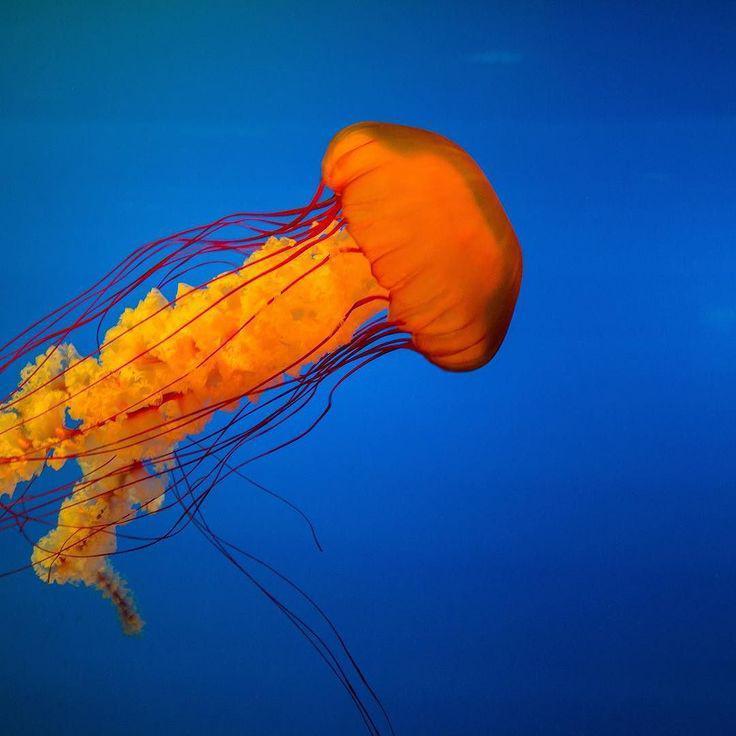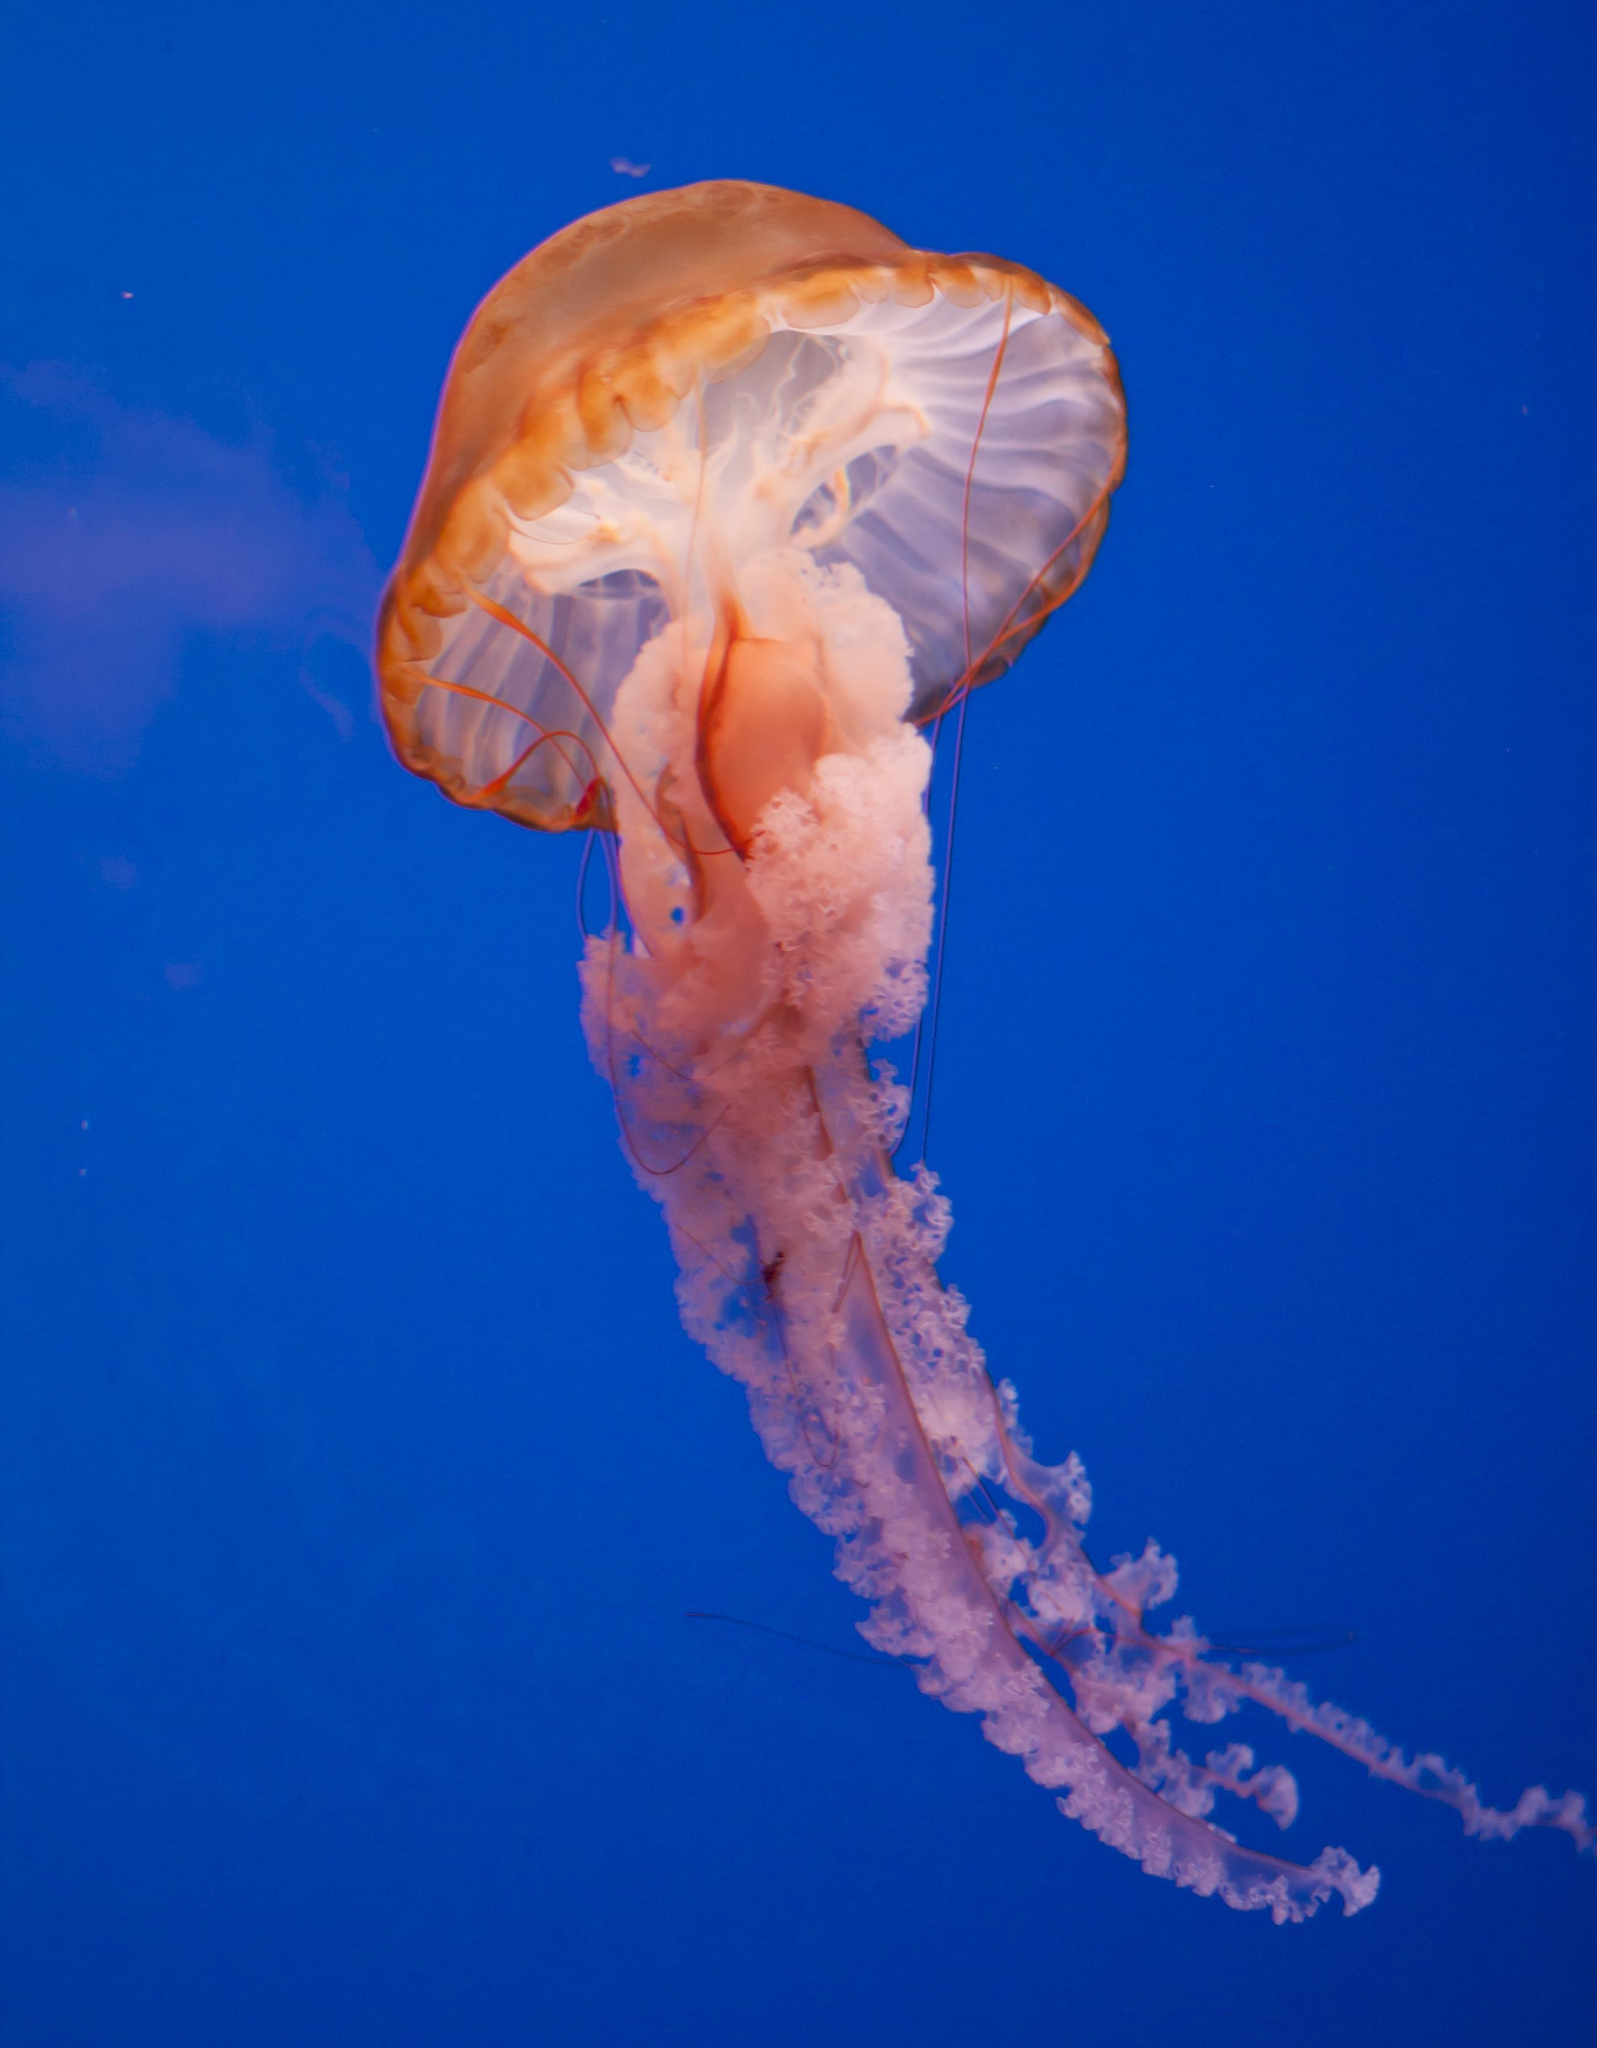The first image is the image on the left, the second image is the image on the right. Evaluate the accuracy of this statement regarding the images: "There are pale pink jellyfish with a clear blue background". Is it true? Answer yes or no. No. 